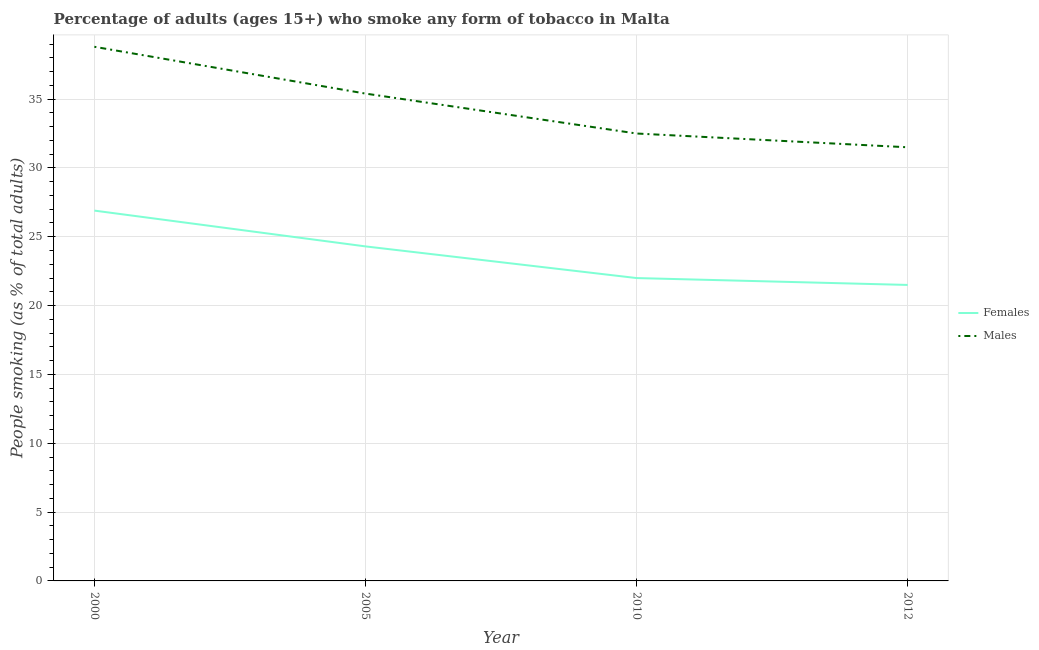What is the percentage of males who smoke in 2005?
Make the answer very short. 35.4. Across all years, what is the maximum percentage of males who smoke?
Give a very brief answer. 38.8. In which year was the percentage of females who smoke maximum?
Keep it short and to the point. 2000. In which year was the percentage of females who smoke minimum?
Offer a terse response. 2012. What is the total percentage of females who smoke in the graph?
Give a very brief answer. 94.7. What is the difference between the percentage of males who smoke in 2000 and that in 2010?
Your response must be concise. 6.3. What is the difference between the percentage of males who smoke in 2012 and the percentage of females who smoke in 2010?
Provide a short and direct response. 9.5. What is the average percentage of males who smoke per year?
Offer a terse response. 34.55. In the year 2012, what is the difference between the percentage of males who smoke and percentage of females who smoke?
Offer a very short reply. 10. What is the ratio of the percentage of females who smoke in 2005 to that in 2012?
Offer a very short reply. 1.13. What is the difference between the highest and the second highest percentage of females who smoke?
Your response must be concise. 2.6. What is the difference between the highest and the lowest percentage of females who smoke?
Make the answer very short. 5.4. In how many years, is the percentage of males who smoke greater than the average percentage of males who smoke taken over all years?
Give a very brief answer. 2. Does the percentage of males who smoke monotonically increase over the years?
Your answer should be compact. No. Is the percentage of males who smoke strictly greater than the percentage of females who smoke over the years?
Make the answer very short. Yes. How many years are there in the graph?
Offer a terse response. 4. Does the graph contain grids?
Offer a terse response. Yes. Where does the legend appear in the graph?
Provide a succinct answer. Center right. How many legend labels are there?
Keep it short and to the point. 2. How are the legend labels stacked?
Give a very brief answer. Vertical. What is the title of the graph?
Provide a short and direct response. Percentage of adults (ages 15+) who smoke any form of tobacco in Malta. What is the label or title of the X-axis?
Offer a terse response. Year. What is the label or title of the Y-axis?
Keep it short and to the point. People smoking (as % of total adults). What is the People smoking (as % of total adults) in Females in 2000?
Keep it short and to the point. 26.9. What is the People smoking (as % of total adults) in Males in 2000?
Make the answer very short. 38.8. What is the People smoking (as % of total adults) in Females in 2005?
Your response must be concise. 24.3. What is the People smoking (as % of total adults) in Males in 2005?
Give a very brief answer. 35.4. What is the People smoking (as % of total adults) of Females in 2010?
Provide a short and direct response. 22. What is the People smoking (as % of total adults) of Males in 2010?
Ensure brevity in your answer.  32.5. What is the People smoking (as % of total adults) in Males in 2012?
Your response must be concise. 31.5. Across all years, what is the maximum People smoking (as % of total adults) of Females?
Ensure brevity in your answer.  26.9. Across all years, what is the maximum People smoking (as % of total adults) in Males?
Make the answer very short. 38.8. Across all years, what is the minimum People smoking (as % of total adults) of Males?
Your response must be concise. 31.5. What is the total People smoking (as % of total adults) of Females in the graph?
Ensure brevity in your answer.  94.7. What is the total People smoking (as % of total adults) of Males in the graph?
Offer a terse response. 138.2. What is the difference between the People smoking (as % of total adults) of Males in 2000 and that in 2005?
Provide a short and direct response. 3.4. What is the difference between the People smoking (as % of total adults) in Females in 2000 and that in 2010?
Provide a succinct answer. 4.9. What is the difference between the People smoking (as % of total adults) of Males in 2000 and that in 2010?
Keep it short and to the point. 6.3. What is the difference between the People smoking (as % of total adults) of Females in 2000 and that in 2012?
Provide a short and direct response. 5.4. What is the difference between the People smoking (as % of total adults) in Females in 2005 and that in 2010?
Offer a terse response. 2.3. What is the difference between the People smoking (as % of total adults) in Males in 2005 and that in 2010?
Offer a very short reply. 2.9. What is the difference between the People smoking (as % of total adults) of Females in 2010 and that in 2012?
Your answer should be compact. 0.5. What is the difference between the People smoking (as % of total adults) in Females in 2000 and the People smoking (as % of total adults) in Males in 2005?
Your answer should be compact. -8.5. What is the difference between the People smoking (as % of total adults) of Females in 2005 and the People smoking (as % of total adults) of Males in 2012?
Your response must be concise. -7.2. What is the average People smoking (as % of total adults) of Females per year?
Your answer should be compact. 23.68. What is the average People smoking (as % of total adults) of Males per year?
Offer a terse response. 34.55. In the year 2005, what is the difference between the People smoking (as % of total adults) of Females and People smoking (as % of total adults) of Males?
Your answer should be very brief. -11.1. In the year 2010, what is the difference between the People smoking (as % of total adults) in Females and People smoking (as % of total adults) in Males?
Make the answer very short. -10.5. What is the ratio of the People smoking (as % of total adults) of Females in 2000 to that in 2005?
Your answer should be compact. 1.11. What is the ratio of the People smoking (as % of total adults) in Males in 2000 to that in 2005?
Your response must be concise. 1.1. What is the ratio of the People smoking (as % of total adults) in Females in 2000 to that in 2010?
Ensure brevity in your answer.  1.22. What is the ratio of the People smoking (as % of total adults) in Males in 2000 to that in 2010?
Keep it short and to the point. 1.19. What is the ratio of the People smoking (as % of total adults) of Females in 2000 to that in 2012?
Provide a short and direct response. 1.25. What is the ratio of the People smoking (as % of total adults) of Males in 2000 to that in 2012?
Provide a succinct answer. 1.23. What is the ratio of the People smoking (as % of total adults) in Females in 2005 to that in 2010?
Your answer should be very brief. 1.1. What is the ratio of the People smoking (as % of total adults) in Males in 2005 to that in 2010?
Give a very brief answer. 1.09. What is the ratio of the People smoking (as % of total adults) in Females in 2005 to that in 2012?
Ensure brevity in your answer.  1.13. What is the ratio of the People smoking (as % of total adults) in Males in 2005 to that in 2012?
Provide a short and direct response. 1.12. What is the ratio of the People smoking (as % of total adults) in Females in 2010 to that in 2012?
Offer a terse response. 1.02. What is the ratio of the People smoking (as % of total adults) of Males in 2010 to that in 2012?
Provide a succinct answer. 1.03. What is the difference between the highest and the second highest People smoking (as % of total adults) of Females?
Ensure brevity in your answer.  2.6. What is the difference between the highest and the second highest People smoking (as % of total adults) in Males?
Keep it short and to the point. 3.4. What is the difference between the highest and the lowest People smoking (as % of total adults) in Females?
Provide a succinct answer. 5.4. 